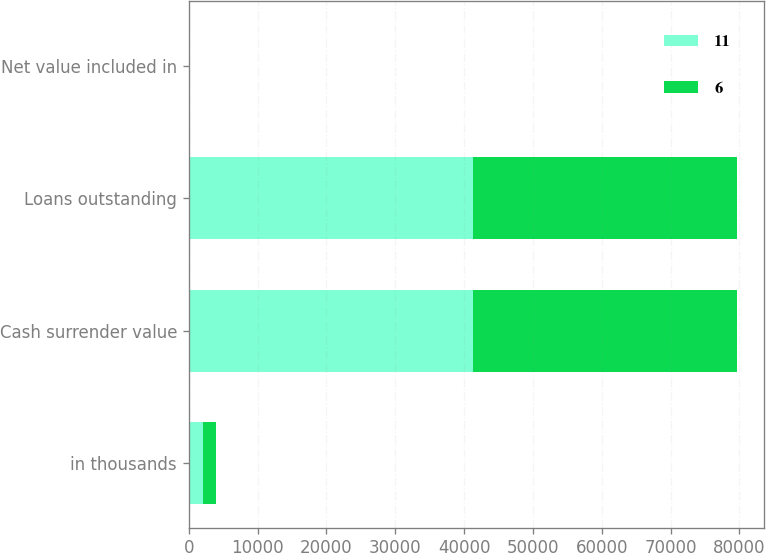Convert chart. <chart><loc_0><loc_0><loc_500><loc_500><stacked_bar_chart><ecel><fcel>in thousands<fcel>Cash surrender value<fcel>Loans outstanding<fcel>Net value included in<nl><fcel>11<fcel>2012<fcel>41351<fcel>41345<fcel>6<nl><fcel>6<fcel>2011<fcel>38300<fcel>38289<fcel>11<nl></chart> 